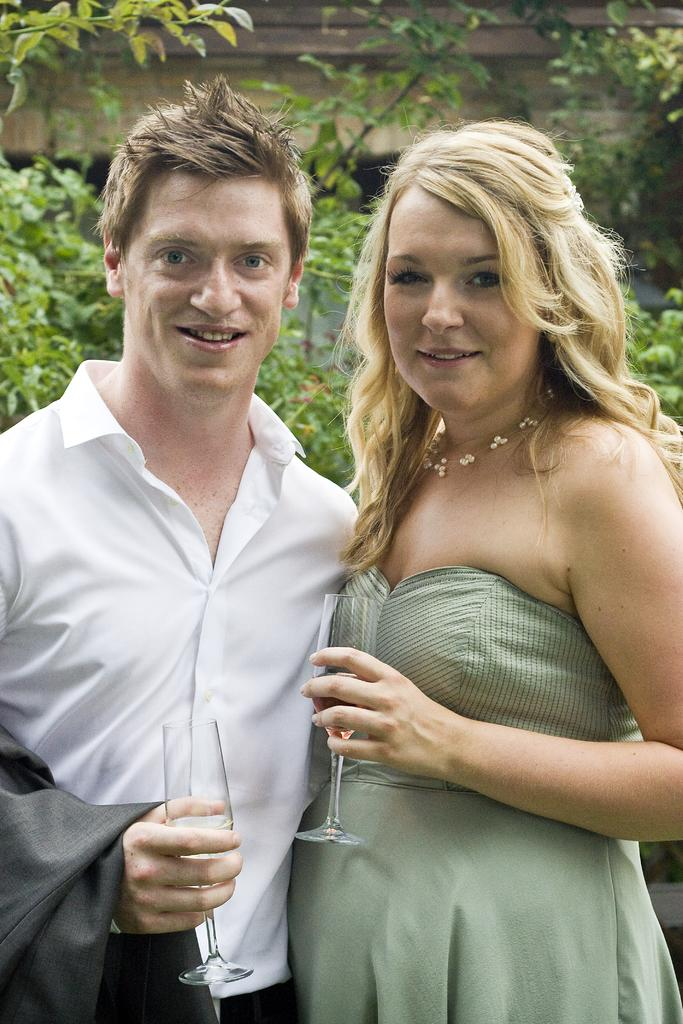Who is present in the image? There is a couple in the image. What is the couple doing in the image? The couple is smiling and holding wine glasses. What can be seen in the background of the image? There are trees visible in the background of the image. What type of underwear is the man wearing in the image? There is no information about the man's underwear in the image, as it is not visible or mentioned in the provided facts. 